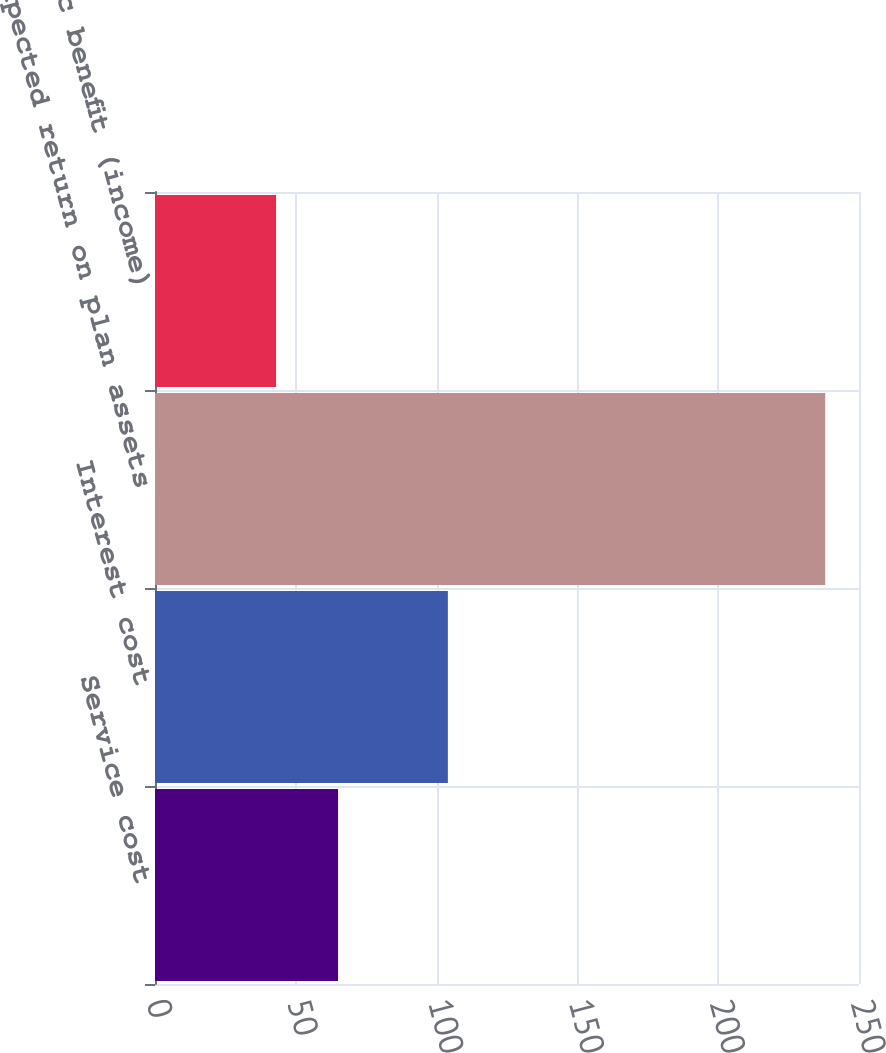Convert chart. <chart><loc_0><loc_0><loc_500><loc_500><bar_chart><fcel>Service cost<fcel>Interest cost<fcel>Expected return on plan assets<fcel>Net periodic benefit (income)<nl><fcel>65<fcel>104<fcel>238<fcel>43<nl></chart> 